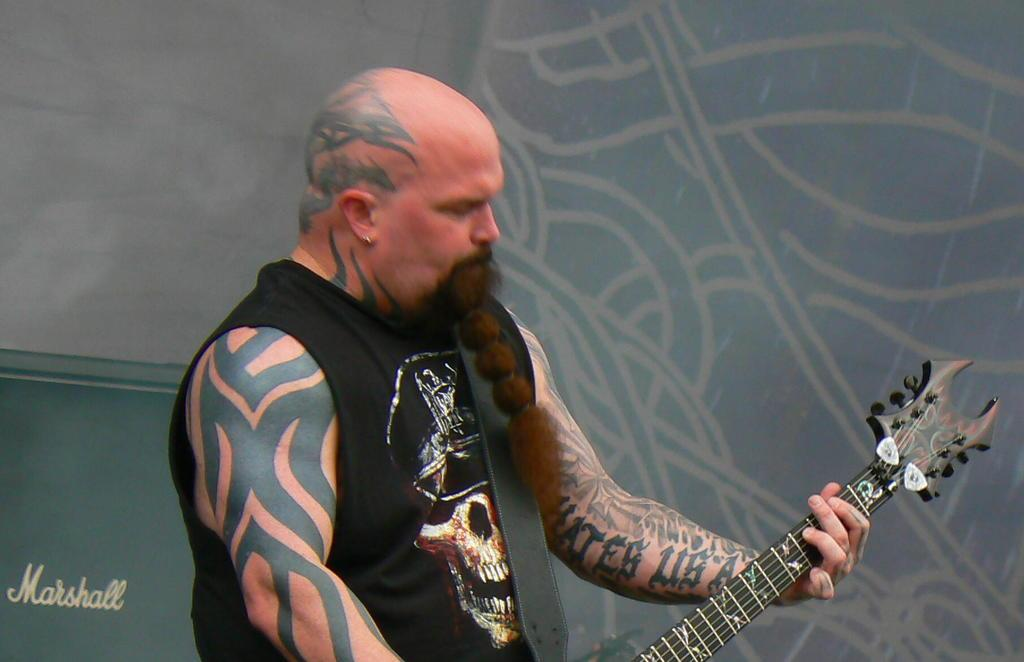What is the main subject of the image? The main subject of the image is a man. What is the man doing in the image? The man is standing in the image. What object is the man holding in the image? The man is holding a guitar in his hands. Are there any distinguishing features on the man's body? Yes, the man has tattoos on his body. What type of skirt is the man wearing in the image? The man is not wearing a skirt in the image; he is wearing clothing appropriate for holding a guitar. 